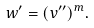Convert formula to latex. <formula><loc_0><loc_0><loc_500><loc_500>w ^ { \prime } = ( v ^ { \prime \prime } ) ^ { m } .</formula> 